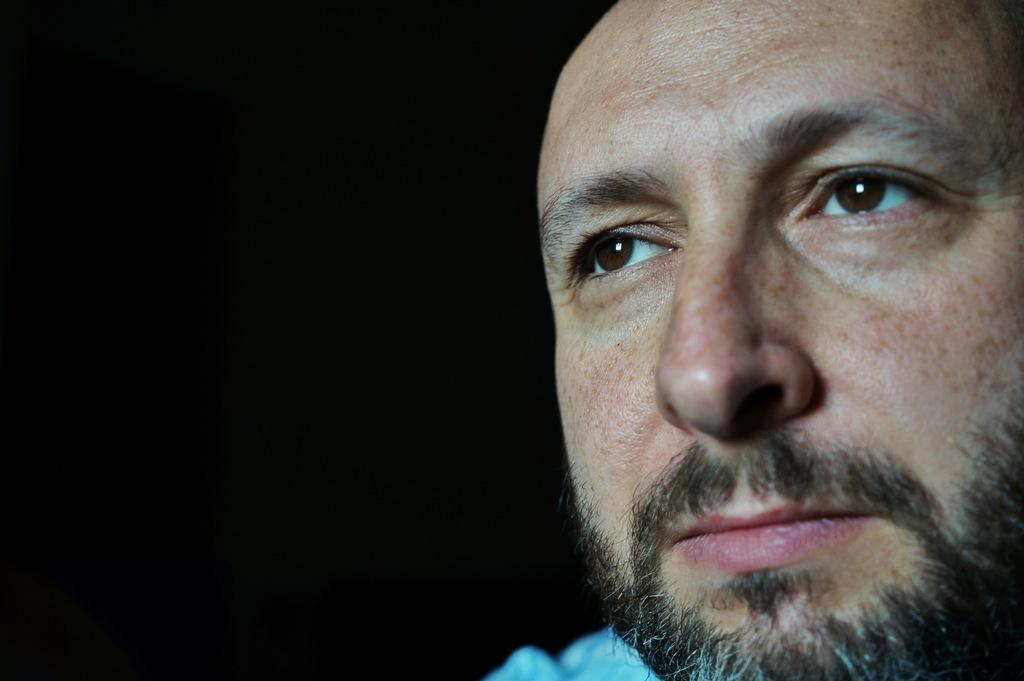What is the main subject of the image? The main subject of the image is a person's face. Can you see an owl in the image? There is no owl present in the image; it features a person's face. What type of harmony is the grandfather playing in the image? There is no grandfather or any musical instrument present in the image, so it's not possible to determine what type of harmony might be played. 